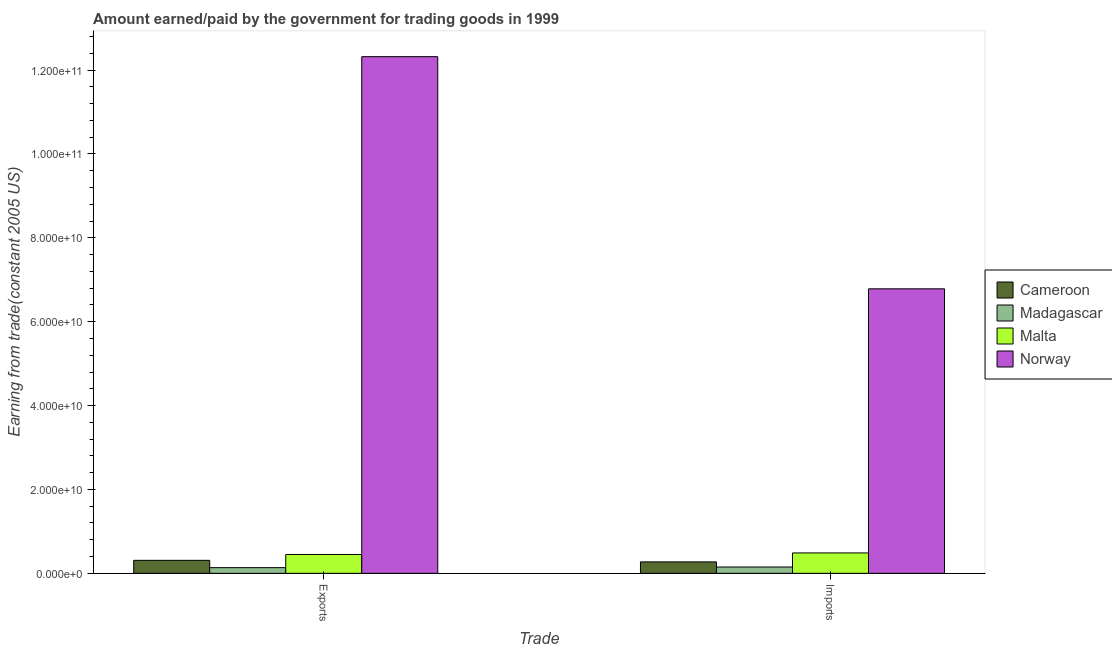Are the number of bars per tick equal to the number of legend labels?
Keep it short and to the point. Yes. Are the number of bars on each tick of the X-axis equal?
Your answer should be compact. Yes. How many bars are there on the 2nd tick from the left?
Provide a succinct answer. 4. How many bars are there on the 2nd tick from the right?
Keep it short and to the point. 4. What is the label of the 1st group of bars from the left?
Your answer should be very brief. Exports. What is the amount paid for imports in Norway?
Your response must be concise. 6.78e+1. Across all countries, what is the maximum amount earned from exports?
Make the answer very short. 1.23e+11. Across all countries, what is the minimum amount earned from exports?
Ensure brevity in your answer.  1.35e+09. In which country was the amount earned from exports maximum?
Your answer should be very brief. Norway. In which country was the amount paid for imports minimum?
Offer a very short reply. Madagascar. What is the total amount earned from exports in the graph?
Keep it short and to the point. 1.32e+11. What is the difference between the amount earned from exports in Madagascar and that in Cameroon?
Give a very brief answer. -1.74e+09. What is the difference between the amount earned from exports in Madagascar and the amount paid for imports in Malta?
Offer a terse response. -3.51e+09. What is the average amount paid for imports per country?
Offer a very short reply. 1.92e+1. What is the difference between the amount paid for imports and amount earned from exports in Madagascar?
Provide a short and direct response. 1.53e+08. In how many countries, is the amount paid for imports greater than 104000000000 US$?
Ensure brevity in your answer.  0. What is the ratio of the amount earned from exports in Madagascar to that in Cameroon?
Your answer should be compact. 0.44. Is the amount earned from exports in Norway less than that in Cameroon?
Your answer should be compact. No. In how many countries, is the amount paid for imports greater than the average amount paid for imports taken over all countries?
Give a very brief answer. 1. What does the 1st bar from the left in Exports represents?
Give a very brief answer. Cameroon. How many bars are there?
Provide a short and direct response. 8. Are all the bars in the graph horizontal?
Your answer should be compact. No. How many countries are there in the graph?
Keep it short and to the point. 4. What is the difference between two consecutive major ticks on the Y-axis?
Offer a terse response. 2.00e+1. Does the graph contain any zero values?
Offer a terse response. No. Does the graph contain grids?
Provide a short and direct response. No. Where does the legend appear in the graph?
Ensure brevity in your answer.  Center right. What is the title of the graph?
Your response must be concise. Amount earned/paid by the government for trading goods in 1999. Does "Venezuela" appear as one of the legend labels in the graph?
Offer a terse response. No. What is the label or title of the X-axis?
Provide a succinct answer. Trade. What is the label or title of the Y-axis?
Provide a short and direct response. Earning from trade(constant 2005 US). What is the Earning from trade(constant 2005 US) of Cameroon in Exports?
Ensure brevity in your answer.  3.10e+09. What is the Earning from trade(constant 2005 US) in Madagascar in Exports?
Give a very brief answer. 1.35e+09. What is the Earning from trade(constant 2005 US) of Malta in Exports?
Offer a very short reply. 4.50e+09. What is the Earning from trade(constant 2005 US) in Norway in Exports?
Offer a terse response. 1.23e+11. What is the Earning from trade(constant 2005 US) in Cameroon in Imports?
Offer a very short reply. 2.73e+09. What is the Earning from trade(constant 2005 US) of Madagascar in Imports?
Give a very brief answer. 1.51e+09. What is the Earning from trade(constant 2005 US) of Malta in Imports?
Make the answer very short. 4.86e+09. What is the Earning from trade(constant 2005 US) in Norway in Imports?
Offer a very short reply. 6.78e+1. Across all Trade, what is the maximum Earning from trade(constant 2005 US) of Cameroon?
Provide a short and direct response. 3.10e+09. Across all Trade, what is the maximum Earning from trade(constant 2005 US) of Madagascar?
Your response must be concise. 1.51e+09. Across all Trade, what is the maximum Earning from trade(constant 2005 US) in Malta?
Provide a succinct answer. 4.86e+09. Across all Trade, what is the maximum Earning from trade(constant 2005 US) in Norway?
Your response must be concise. 1.23e+11. Across all Trade, what is the minimum Earning from trade(constant 2005 US) of Cameroon?
Provide a succinct answer. 2.73e+09. Across all Trade, what is the minimum Earning from trade(constant 2005 US) of Madagascar?
Offer a terse response. 1.35e+09. Across all Trade, what is the minimum Earning from trade(constant 2005 US) in Malta?
Your answer should be very brief. 4.50e+09. Across all Trade, what is the minimum Earning from trade(constant 2005 US) of Norway?
Offer a terse response. 6.78e+1. What is the total Earning from trade(constant 2005 US) in Cameroon in the graph?
Give a very brief answer. 5.83e+09. What is the total Earning from trade(constant 2005 US) of Madagascar in the graph?
Your response must be concise. 2.86e+09. What is the total Earning from trade(constant 2005 US) in Malta in the graph?
Offer a very short reply. 9.36e+09. What is the total Earning from trade(constant 2005 US) in Norway in the graph?
Provide a short and direct response. 1.91e+11. What is the difference between the Earning from trade(constant 2005 US) of Cameroon in Exports and that in Imports?
Your response must be concise. 3.73e+08. What is the difference between the Earning from trade(constant 2005 US) in Madagascar in Exports and that in Imports?
Make the answer very short. -1.53e+08. What is the difference between the Earning from trade(constant 2005 US) of Malta in Exports and that in Imports?
Ensure brevity in your answer.  -3.67e+08. What is the difference between the Earning from trade(constant 2005 US) of Norway in Exports and that in Imports?
Offer a very short reply. 5.54e+1. What is the difference between the Earning from trade(constant 2005 US) of Cameroon in Exports and the Earning from trade(constant 2005 US) of Madagascar in Imports?
Offer a very short reply. 1.59e+09. What is the difference between the Earning from trade(constant 2005 US) of Cameroon in Exports and the Earning from trade(constant 2005 US) of Malta in Imports?
Give a very brief answer. -1.76e+09. What is the difference between the Earning from trade(constant 2005 US) of Cameroon in Exports and the Earning from trade(constant 2005 US) of Norway in Imports?
Provide a short and direct response. -6.47e+1. What is the difference between the Earning from trade(constant 2005 US) in Madagascar in Exports and the Earning from trade(constant 2005 US) in Malta in Imports?
Provide a short and direct response. -3.51e+09. What is the difference between the Earning from trade(constant 2005 US) in Madagascar in Exports and the Earning from trade(constant 2005 US) in Norway in Imports?
Your answer should be very brief. -6.65e+1. What is the difference between the Earning from trade(constant 2005 US) of Malta in Exports and the Earning from trade(constant 2005 US) of Norway in Imports?
Make the answer very short. -6.33e+1. What is the average Earning from trade(constant 2005 US) in Cameroon per Trade?
Offer a very short reply. 2.91e+09. What is the average Earning from trade(constant 2005 US) in Madagascar per Trade?
Ensure brevity in your answer.  1.43e+09. What is the average Earning from trade(constant 2005 US) of Malta per Trade?
Keep it short and to the point. 4.68e+09. What is the average Earning from trade(constant 2005 US) of Norway per Trade?
Keep it short and to the point. 9.55e+1. What is the difference between the Earning from trade(constant 2005 US) of Cameroon and Earning from trade(constant 2005 US) of Madagascar in Exports?
Provide a succinct answer. 1.74e+09. What is the difference between the Earning from trade(constant 2005 US) in Cameroon and Earning from trade(constant 2005 US) in Malta in Exports?
Provide a short and direct response. -1.40e+09. What is the difference between the Earning from trade(constant 2005 US) of Cameroon and Earning from trade(constant 2005 US) of Norway in Exports?
Your answer should be compact. -1.20e+11. What is the difference between the Earning from trade(constant 2005 US) in Madagascar and Earning from trade(constant 2005 US) in Malta in Exports?
Give a very brief answer. -3.14e+09. What is the difference between the Earning from trade(constant 2005 US) of Madagascar and Earning from trade(constant 2005 US) of Norway in Exports?
Your response must be concise. -1.22e+11. What is the difference between the Earning from trade(constant 2005 US) of Malta and Earning from trade(constant 2005 US) of Norway in Exports?
Your answer should be very brief. -1.19e+11. What is the difference between the Earning from trade(constant 2005 US) in Cameroon and Earning from trade(constant 2005 US) in Madagascar in Imports?
Keep it short and to the point. 1.22e+09. What is the difference between the Earning from trade(constant 2005 US) in Cameroon and Earning from trade(constant 2005 US) in Malta in Imports?
Provide a succinct answer. -2.14e+09. What is the difference between the Earning from trade(constant 2005 US) in Cameroon and Earning from trade(constant 2005 US) in Norway in Imports?
Give a very brief answer. -6.51e+1. What is the difference between the Earning from trade(constant 2005 US) of Madagascar and Earning from trade(constant 2005 US) of Malta in Imports?
Ensure brevity in your answer.  -3.36e+09. What is the difference between the Earning from trade(constant 2005 US) of Madagascar and Earning from trade(constant 2005 US) of Norway in Imports?
Keep it short and to the point. -6.63e+1. What is the difference between the Earning from trade(constant 2005 US) in Malta and Earning from trade(constant 2005 US) in Norway in Imports?
Your answer should be compact. -6.30e+1. What is the ratio of the Earning from trade(constant 2005 US) of Cameroon in Exports to that in Imports?
Your answer should be compact. 1.14. What is the ratio of the Earning from trade(constant 2005 US) of Madagascar in Exports to that in Imports?
Your answer should be very brief. 0.9. What is the ratio of the Earning from trade(constant 2005 US) of Malta in Exports to that in Imports?
Give a very brief answer. 0.92. What is the ratio of the Earning from trade(constant 2005 US) in Norway in Exports to that in Imports?
Your answer should be very brief. 1.82. What is the difference between the highest and the second highest Earning from trade(constant 2005 US) of Cameroon?
Keep it short and to the point. 3.73e+08. What is the difference between the highest and the second highest Earning from trade(constant 2005 US) in Madagascar?
Provide a short and direct response. 1.53e+08. What is the difference between the highest and the second highest Earning from trade(constant 2005 US) of Malta?
Your response must be concise. 3.67e+08. What is the difference between the highest and the second highest Earning from trade(constant 2005 US) in Norway?
Offer a very short reply. 5.54e+1. What is the difference between the highest and the lowest Earning from trade(constant 2005 US) of Cameroon?
Your response must be concise. 3.73e+08. What is the difference between the highest and the lowest Earning from trade(constant 2005 US) of Madagascar?
Provide a short and direct response. 1.53e+08. What is the difference between the highest and the lowest Earning from trade(constant 2005 US) in Malta?
Keep it short and to the point. 3.67e+08. What is the difference between the highest and the lowest Earning from trade(constant 2005 US) in Norway?
Provide a short and direct response. 5.54e+1. 